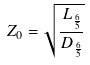<formula> <loc_0><loc_0><loc_500><loc_500>Z _ { 0 } = \sqrt { \frac { L _ { \frac { 6 } { 5 } } } { D _ { \frac { 6 } { 5 } } } }</formula> 